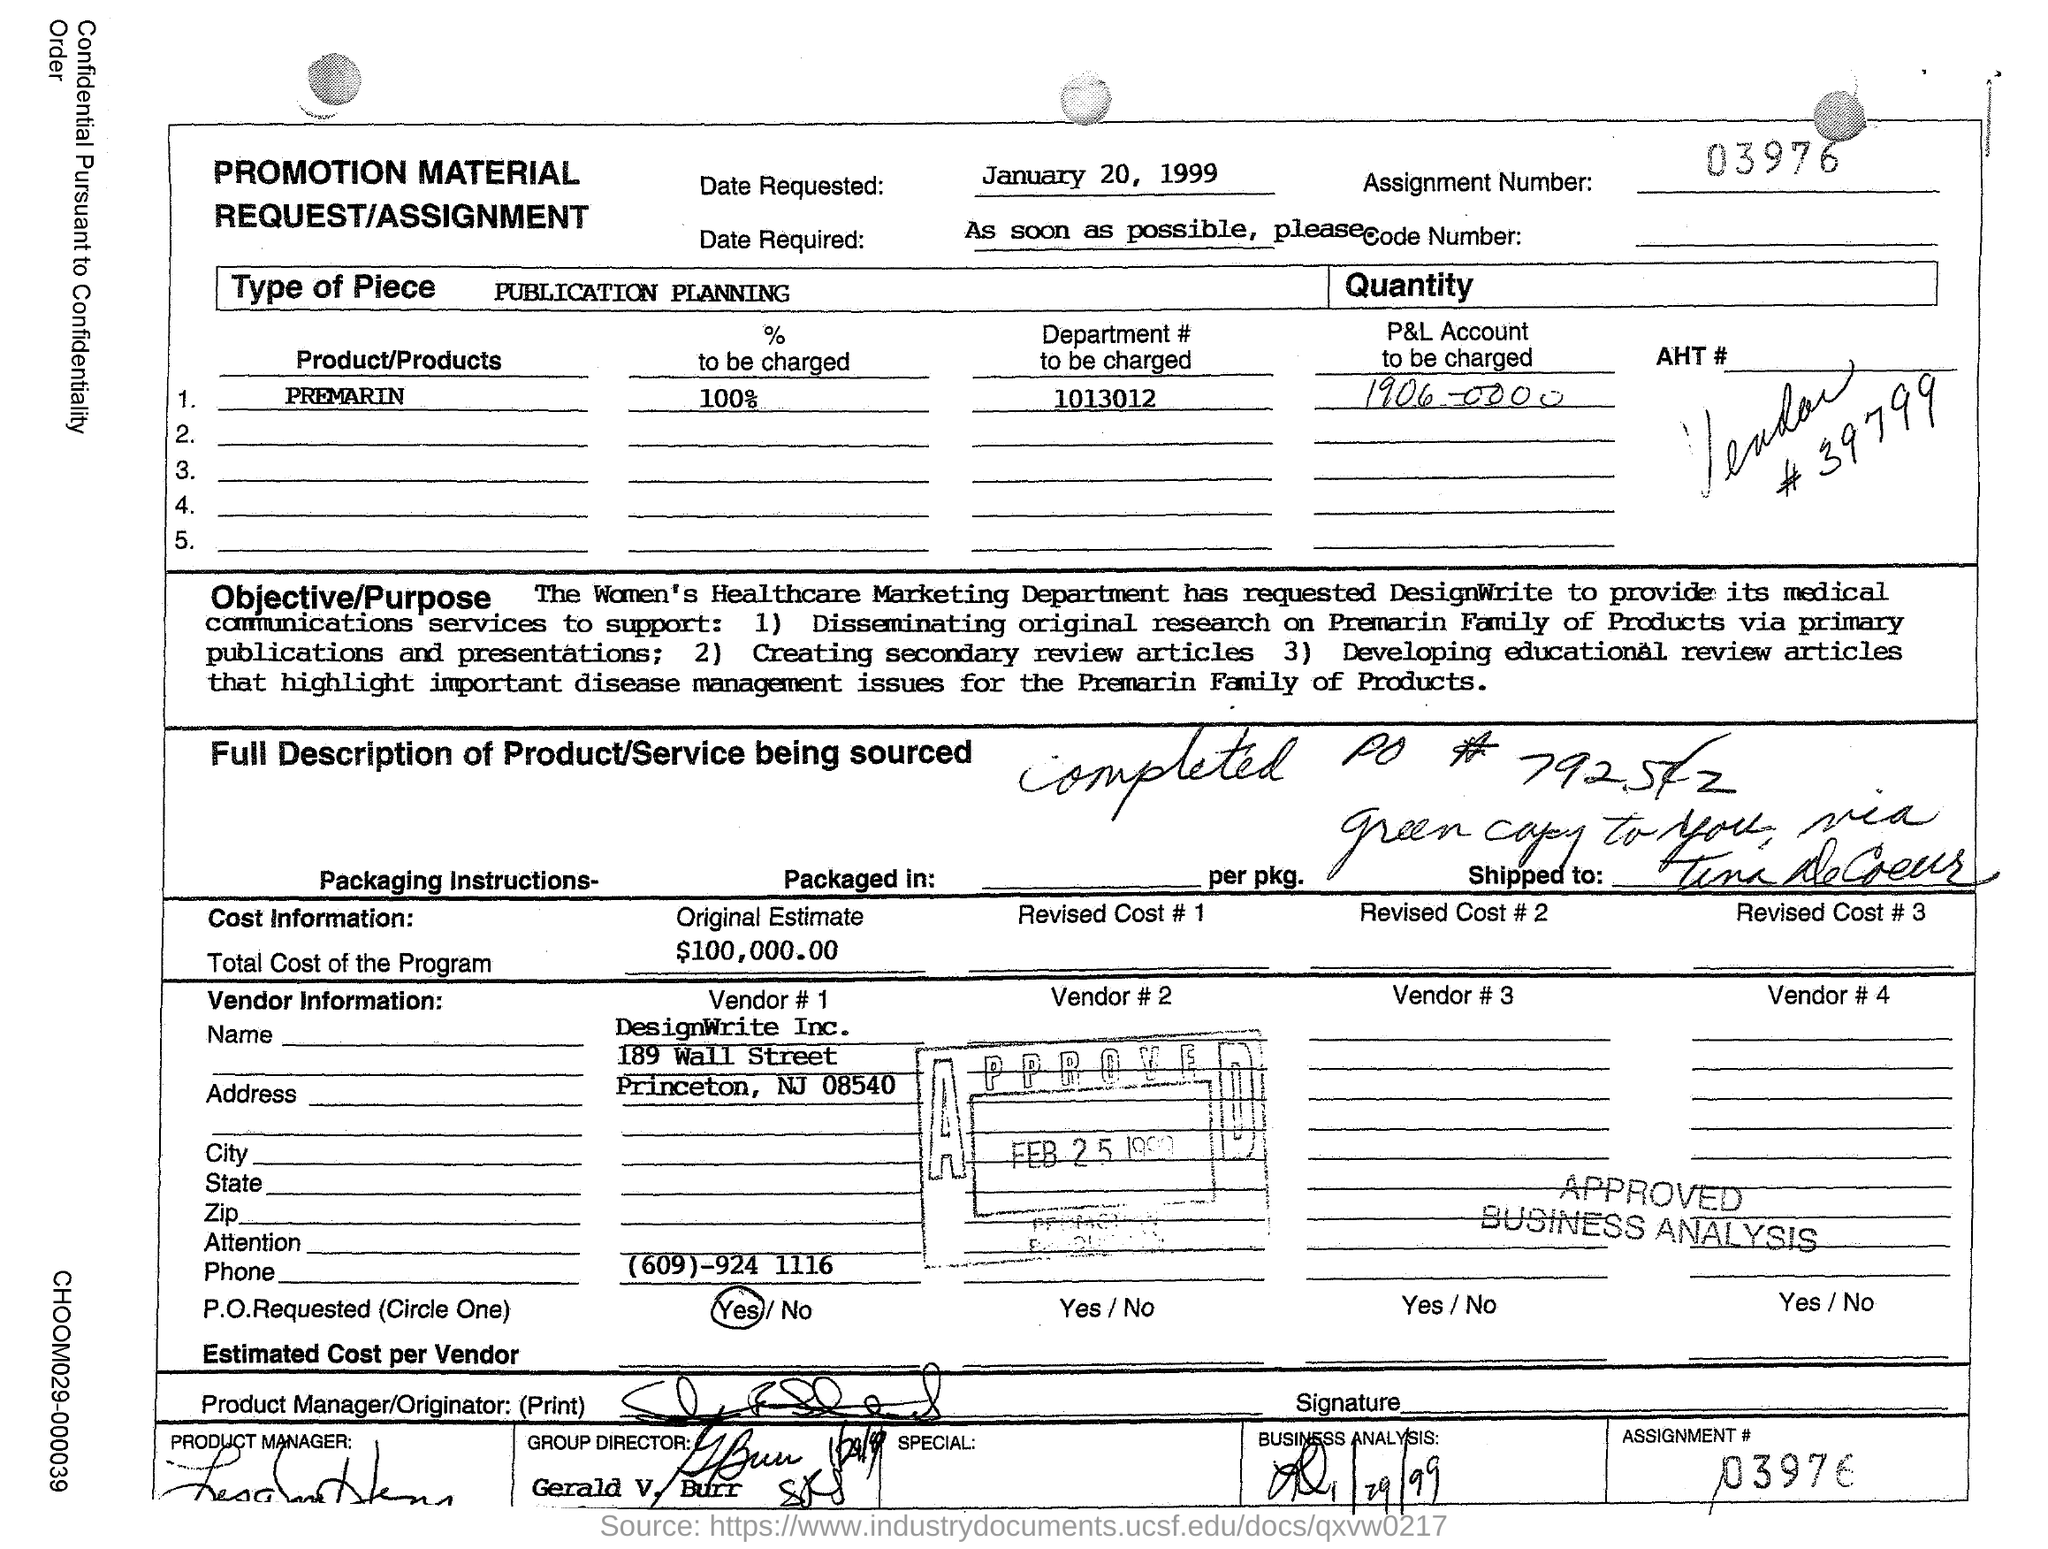What is the date requested?
Your answer should be very brief. January 20, 1999. What is the Assignment Number?
Offer a very short reply. 03976. What is the Product/Products?
Keep it short and to the point. Premarin. How much % to be charged?
Your answer should be very brief. 100%. What is the Department # to be charged?
Your response must be concise. 1013012. What is the P&L Account to be charged?
Your answer should be compact. 1906-0000. What is the Total Cost of the Program?
Your answer should be very brief. $100,000.00. Who is the Vendor # 1?
Keep it short and to the point. DesignWrite Inc. 